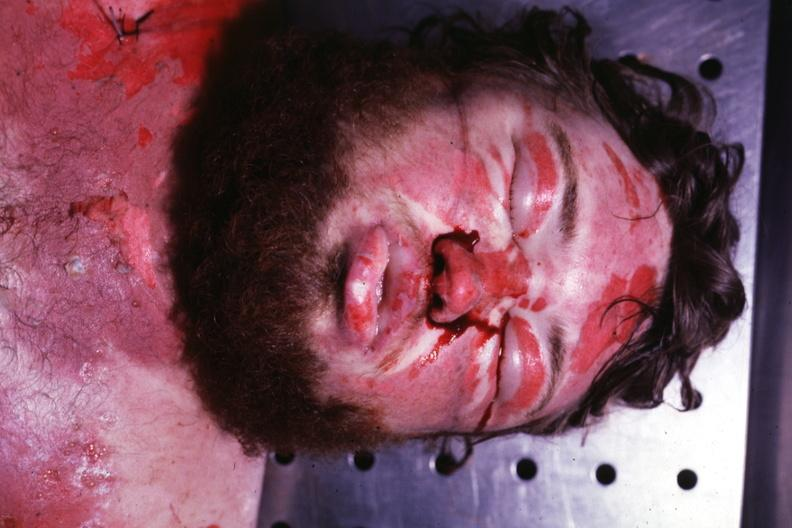s edema present?
Answer the question using a single word or phrase. Yes 